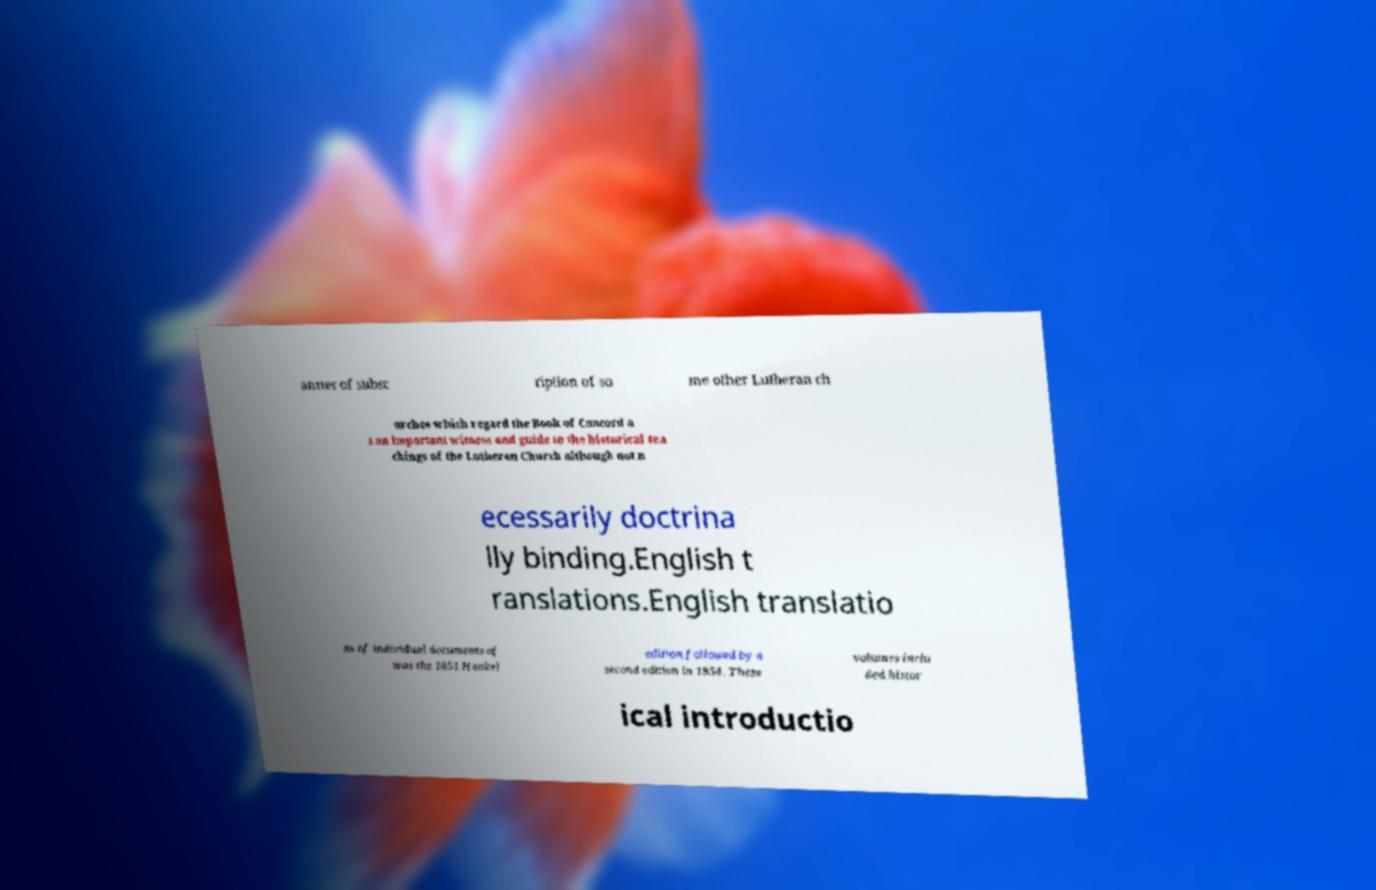Can you read and provide the text displayed in the image?This photo seems to have some interesting text. Can you extract and type it out for me? anner of subsc ription of so me other Lutheran ch urches which regard the Book of Concord a s an important witness and guide to the historical tea chings of the Lutheran Church although not n ecessarily doctrina lly binding.English t ranslations.English translatio ns of individual documents of was the 1851 Henkel edition followed by a second edition in 1854. These volumes inclu ded histor ical introductio 